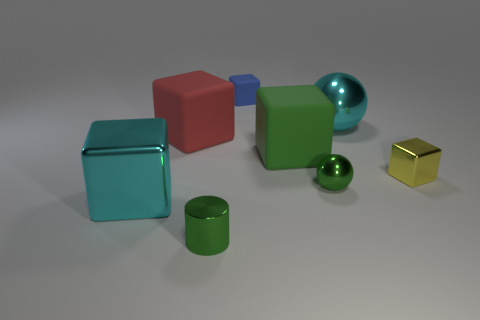Subtract 2 cubes. How many cubes are left? 3 Subtract all purple cubes. Subtract all brown spheres. How many cubes are left? 5 Add 2 metal cylinders. How many objects exist? 10 Subtract all cubes. How many objects are left? 3 Subtract 0 cyan cylinders. How many objects are left? 8 Subtract all brown metallic balls. Subtract all large matte cubes. How many objects are left? 6 Add 7 small green shiny balls. How many small green shiny balls are left? 8 Add 1 large metallic things. How many large metallic things exist? 3 